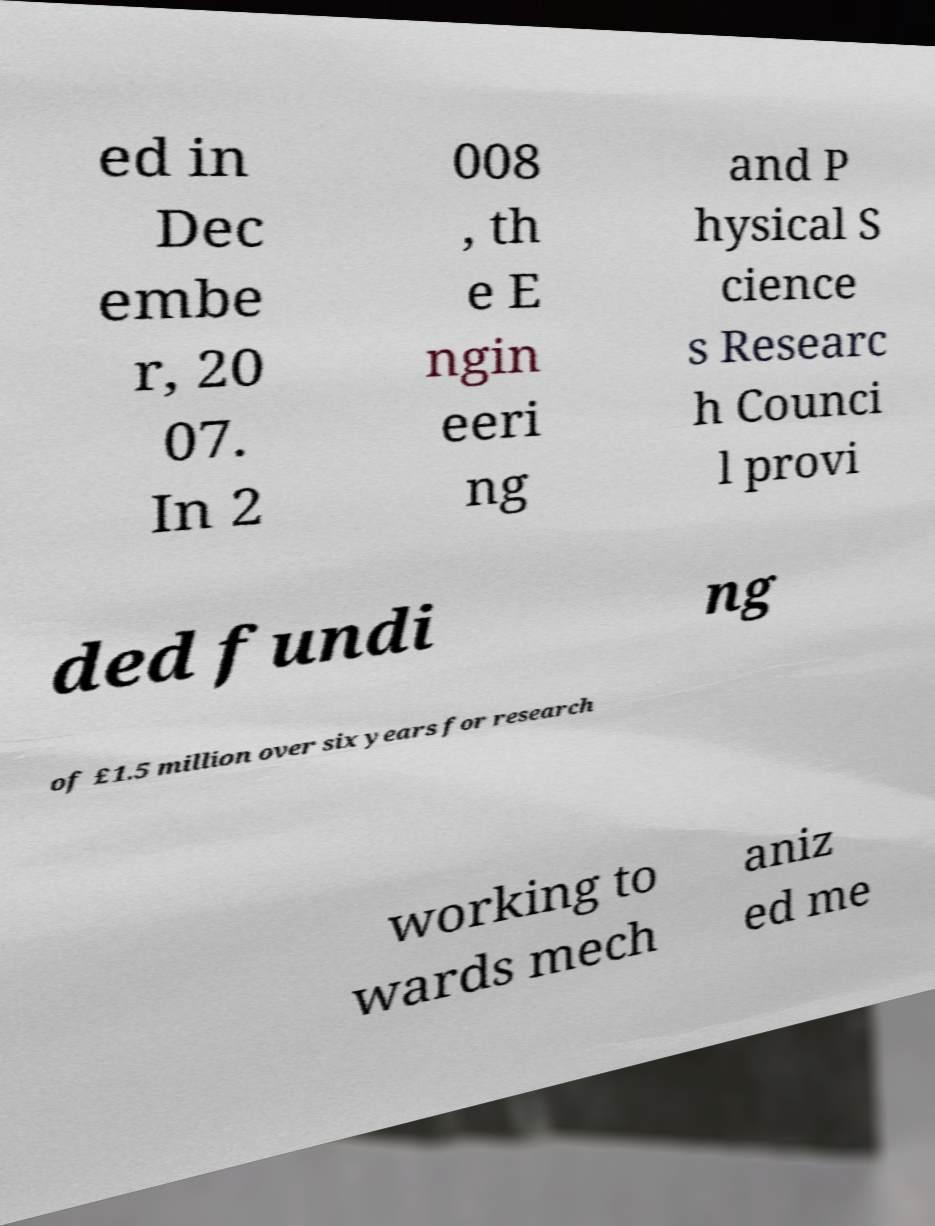Can you accurately transcribe the text from the provided image for me? ed in Dec embe r, 20 07. In 2 008 , th e E ngin eeri ng and P hysical S cience s Researc h Counci l provi ded fundi ng of £1.5 million over six years for research working to wards mech aniz ed me 